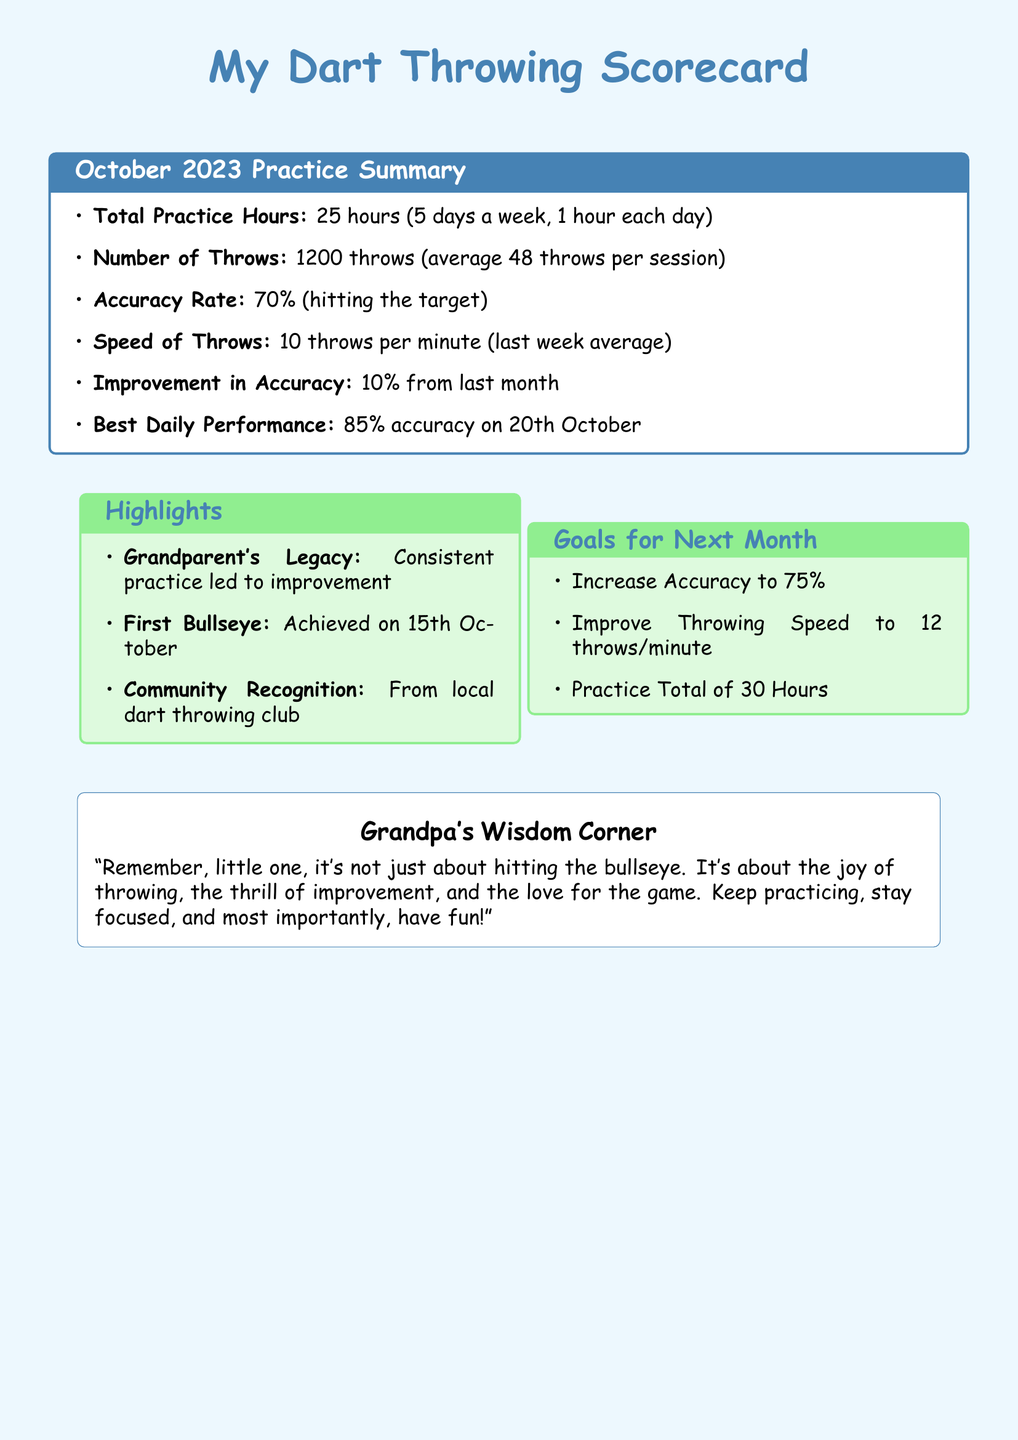What is the total practice hours? The total practice hours is stated in the document, which lists 25 hours of practice.
Answer: 25 hours What was the number of throws? The document specifies that there were 1200 throws made during the practice sessions.
Answer: 1200 throws What is the accuracy rate achieved? The accuracy rate can be found within the summary, which notes a 70% accuracy in hitting the target.
Answer: 70% What improvement in accuracy was noted? The document mentions an improvement in accuracy, stating it increased by 10% from the previous month.
Answer: 10% What was the best daily performance accuracy? To find the best daily performance accuracy, one can reference the date provided in the scorecard, which is 85%.
Answer: 85% What is the goal for accuracy next month? The goals for the next month specify an increase in accuracy to 75%.
Answer: 75% When was the first bullseye achieved? The scorecard mentions that the first bullseye was achieved on a specific date, which is the 15th of October.
Answer: 15th October How many throws per minute does the speed average? The document indicates a speed of 10 throws per minute for the last week average.
Answer: 10 throws per minute What is one of the goals for total practice hours next month? A goal outlined in the document is to practice a total of 30 hours next month.
Answer: 30 hours 